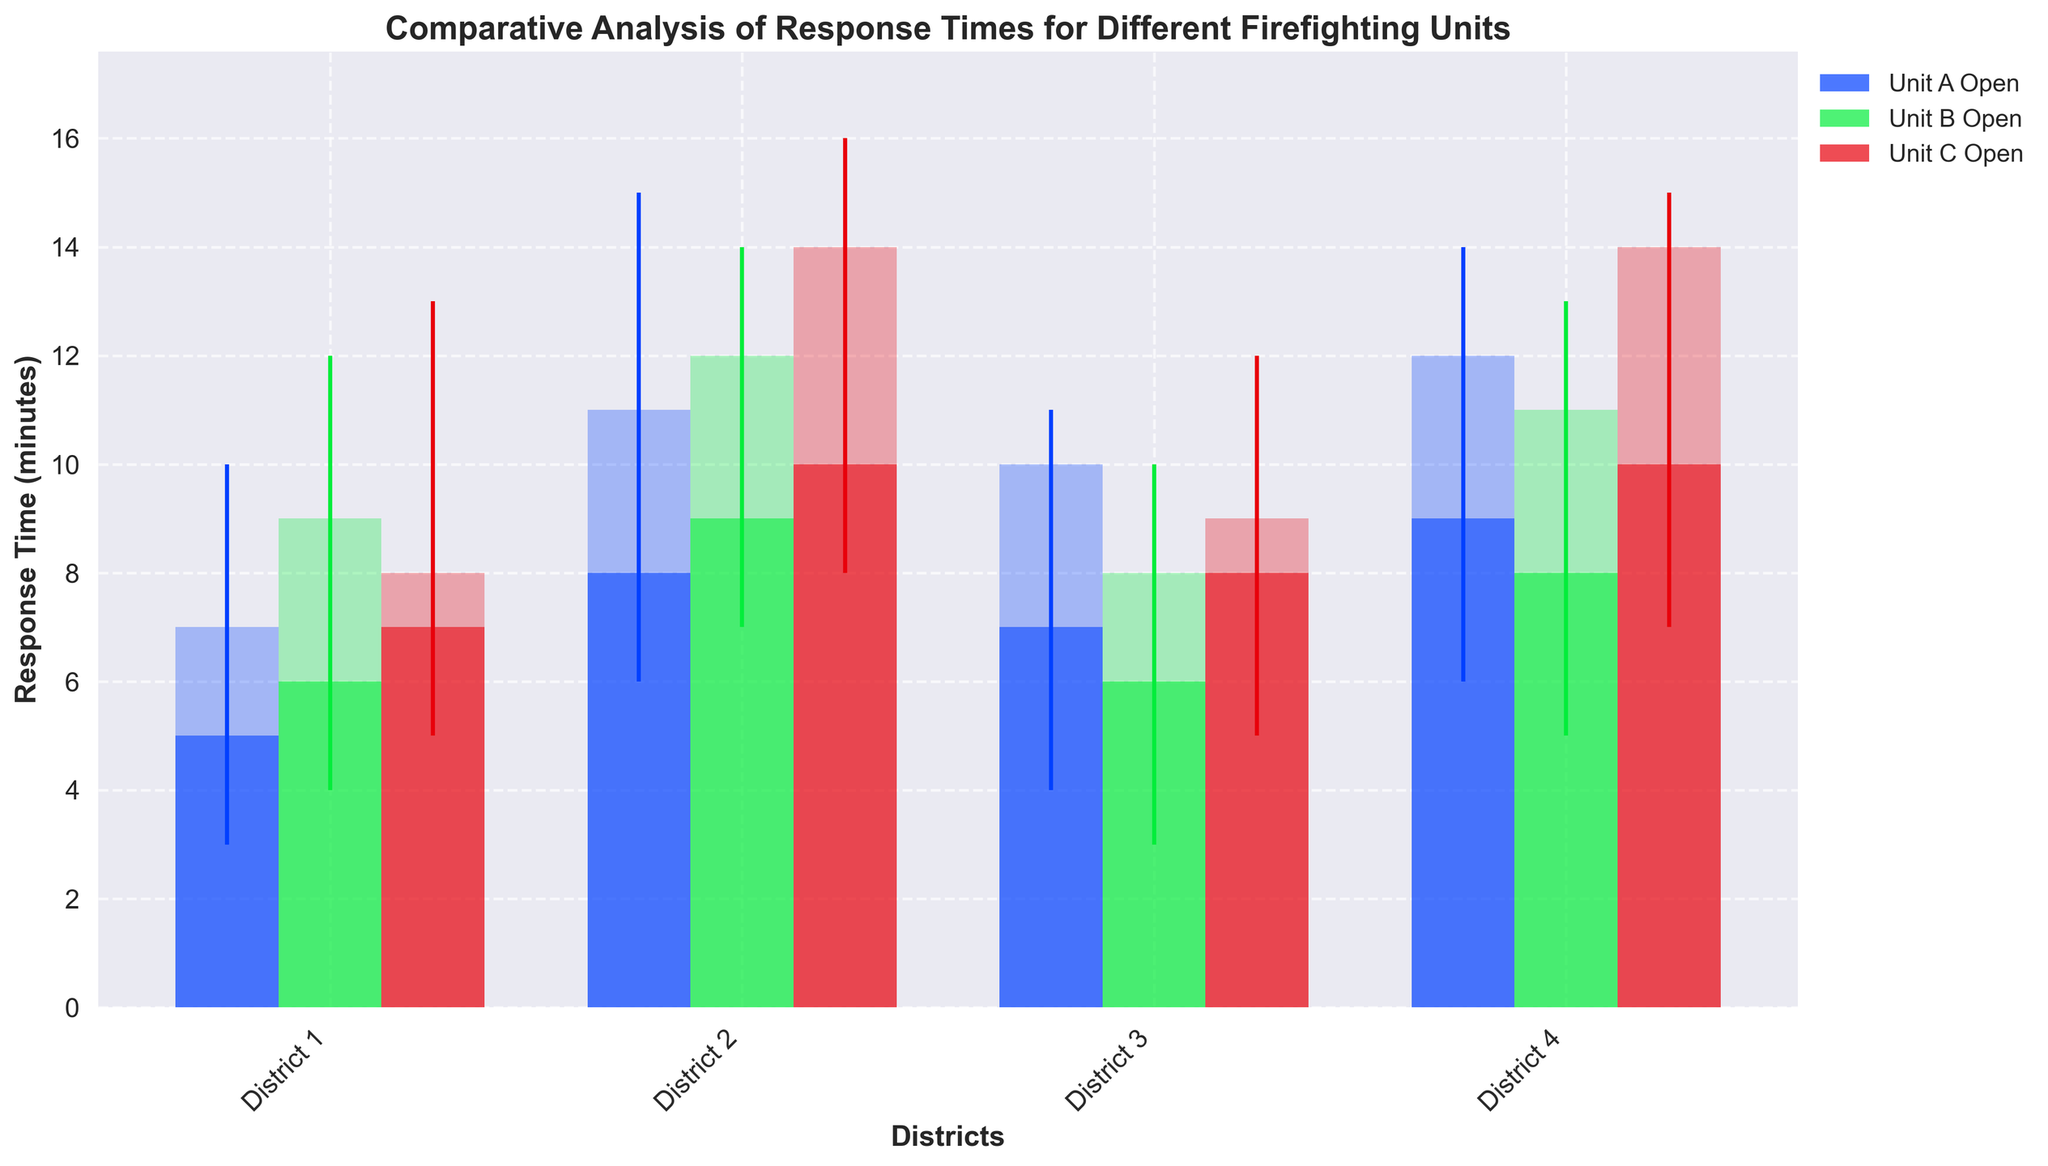What is the title of the plotted figure? The title is typically located at the top center of the figure. Reading it directly tells you the main topic of the plot.
Answer: Comparative Analysis of Response Times for Different Firefighting Units Which unit has the highest recorded response time in District 2? Look for District 2 and identify the unit whose upper end (high) of the candlestick is the highest. This corresponds to Unit C.
Answer: Unit C Are there any districts where Unit A has a faster response time than Unit B based on the closing time? Compare the closing response times (the top part of the filled rectangles) of Unit A and Unit B across all districts. In District 3, Unit A (10) has a faster closing time than Unit B (8).
Answer: District 3 What is the range of response times for Unit B in District 1? The range is the difference between the high and the low values of the candlestick for Unit B in District 1. This corresponds to 12 - 4.
Answer: 8 minutes Which unit shows the least variance in response times across all districts? To determine variance, examine the candlestick lengths (high minus low) for each unit across all districts. Unit A generally shows shorter candlesticks compared to other units.
Answer: Unit A What is the average closing response time for Unit C across all districts? Sum the closing times of Unit C across all districts (8 + 14 + 9 + 14) and divide by the number of districts (4). Calculation: (8 + 14 + 9 + 14) / 4 = 11.25
Answer: 11.25 minutes How do the response times of Unit C in District 3 compare to those in District 4? Compare the open, high, low, and close response times of Unit C between District 3 and District 4. District 3 has (8, 12, 5, 9) whereas District 4 has (10, 15, 7, 14). Unit C in District 4 consistently shows higher response times.
Answer: District 4 has higher response times Which district has the lowest recorded response time, and for which unit? Identify the lowest point on the entire candlestick plot. The lowest response time recorded is for Unit B in District 3 at 3 minutes.
Answer: District 3, Unit B What is the combined high response time of all units in District 1? Sum up the highest points (high values) of the candlesticks for all units in District 1: 10 (Unit A) + 12 (Unit B) + 13 (Unit C) = 35
Answer: 35 minutes 